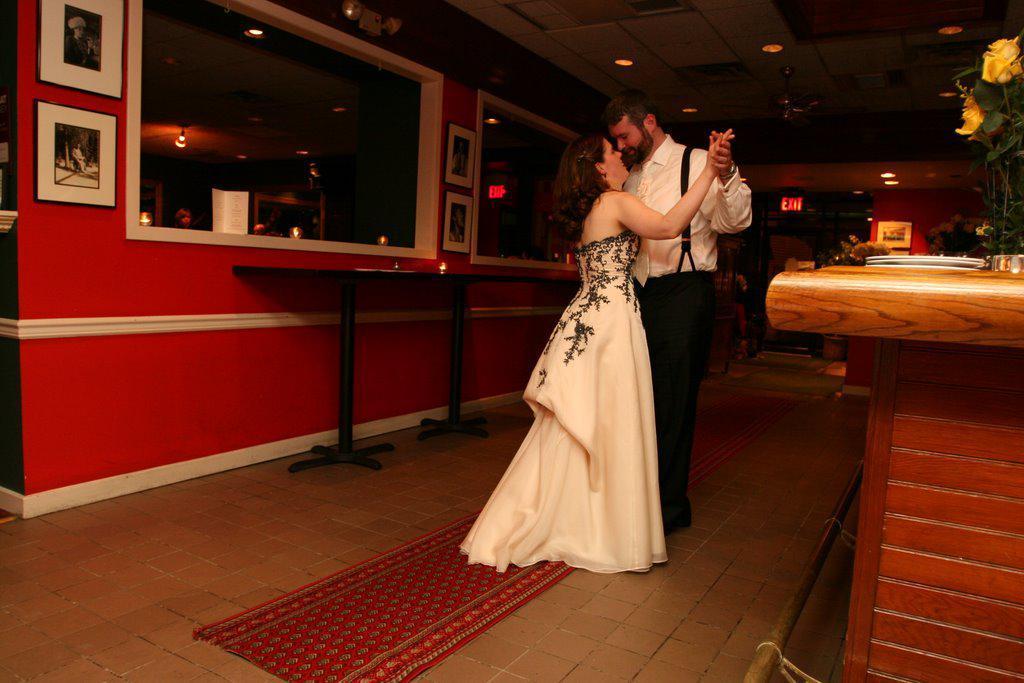In one or two sentences, can you explain what this image depicts? In this picture there is a man and a woman holding their hands. There are frames on the wall. To the right, there is a flower bouquet. Some lights are seen on top There is a card and a table. There is a red carpet. 